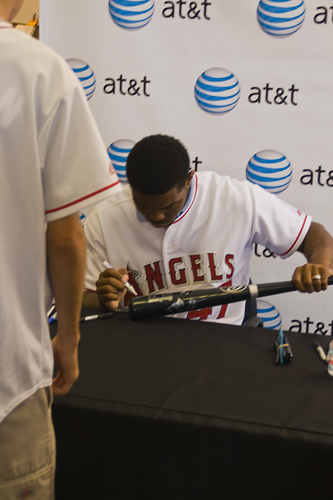Read all the text in this image. at t at t at at&amp; ANGELS at a &amp; t &amp; &amp; 